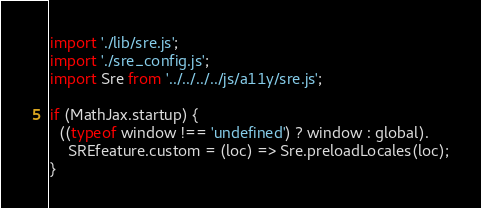Convert code to text. <code><loc_0><loc_0><loc_500><loc_500><_JavaScript_>import './lib/sre.js';
import './sre_config.js';
import Sre from '../../../../js/a11y/sre.js';

if (MathJax.startup) {
  ((typeof window !== 'undefined') ? window : global).
    SREfeature.custom = (loc) => Sre.preloadLocales(loc);
}

</code> 